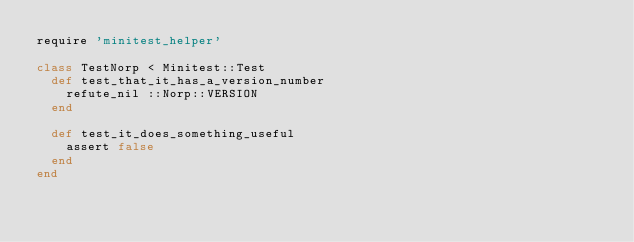<code> <loc_0><loc_0><loc_500><loc_500><_Ruby_>require 'minitest_helper'

class TestNorp < Minitest::Test
  def test_that_it_has_a_version_number
    refute_nil ::Norp::VERSION
  end

  def test_it_does_something_useful
    assert false
  end
end
</code> 